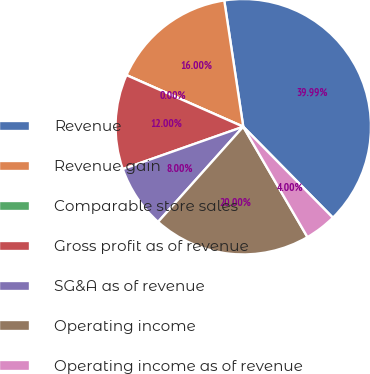<chart> <loc_0><loc_0><loc_500><loc_500><pie_chart><fcel>Revenue<fcel>Revenue gain<fcel>Comparable store sales<fcel>Gross profit as of revenue<fcel>SG&A as of revenue<fcel>Operating income<fcel>Operating income as of revenue<nl><fcel>39.99%<fcel>16.0%<fcel>0.0%<fcel>12.0%<fcel>8.0%<fcel>20.0%<fcel>4.0%<nl></chart> 